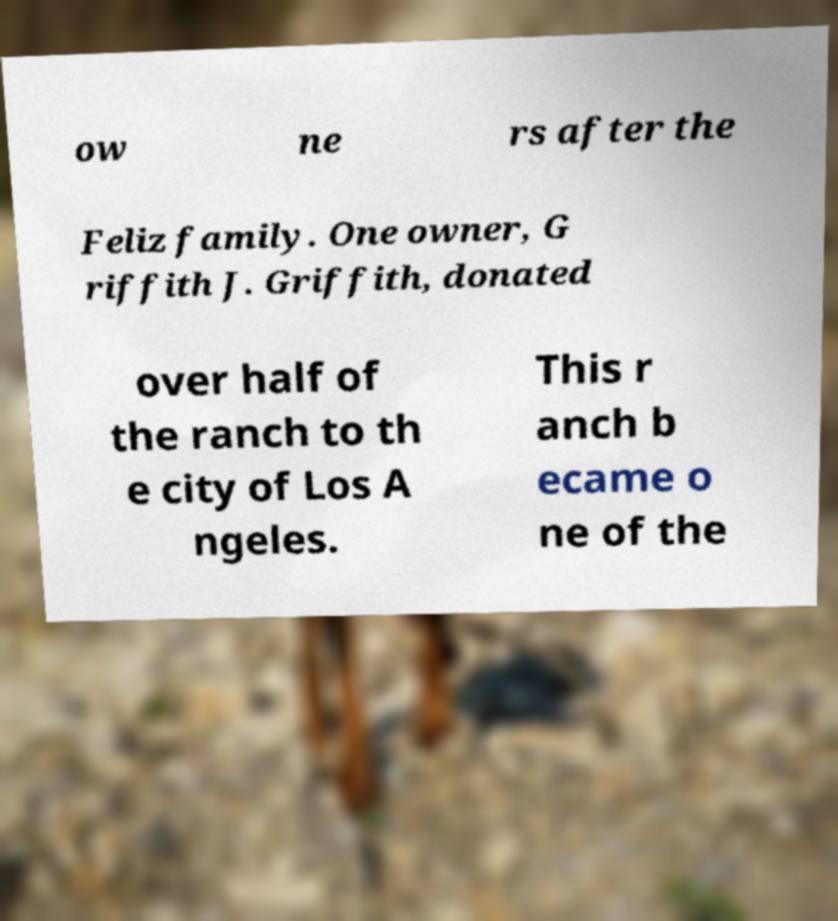Could you extract and type out the text from this image? ow ne rs after the Feliz family. One owner, G riffith J. Griffith, donated over half of the ranch to th e city of Los A ngeles. This r anch b ecame o ne of the 